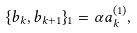Convert formula to latex. <formula><loc_0><loc_0><loc_500><loc_500>\{ b _ { k } , b _ { k + 1 } \} _ { 1 } = \alpha a _ { k } ^ { ( 1 ) } ,</formula> 